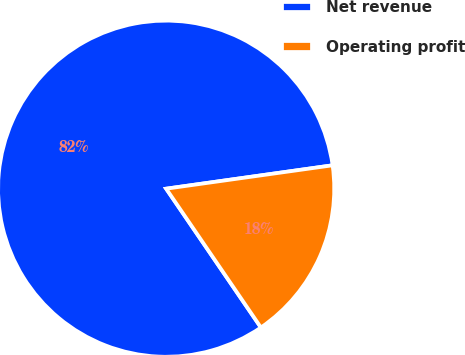Convert chart to OTSL. <chart><loc_0><loc_0><loc_500><loc_500><pie_chart><fcel>Net revenue<fcel>Operating profit<nl><fcel>82.31%<fcel>17.69%<nl></chart> 